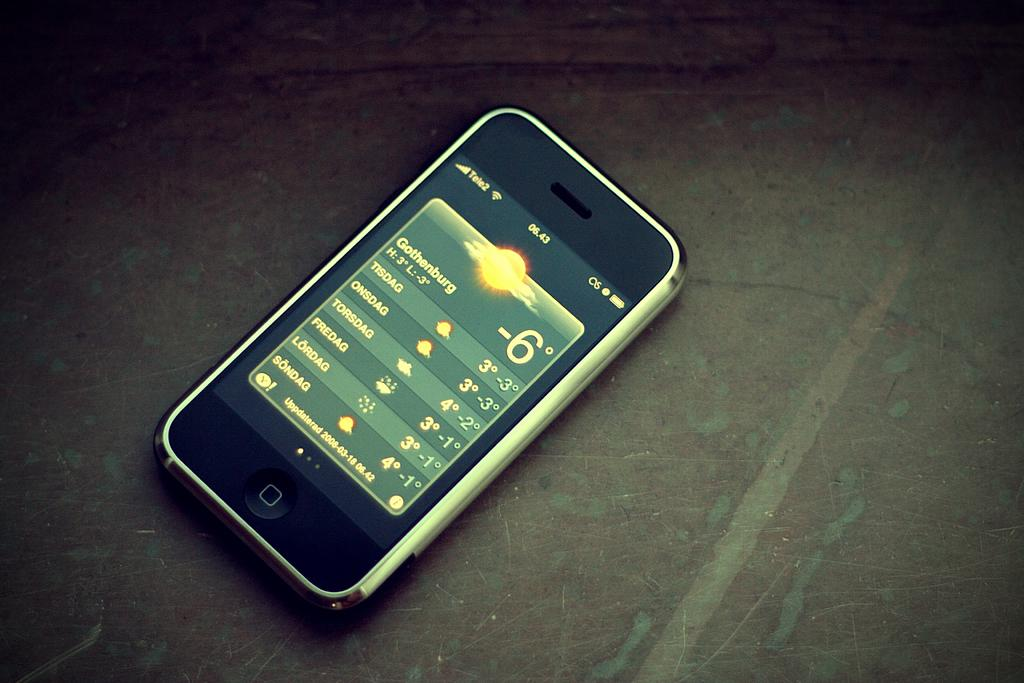<image>
Describe the image concisely. An older iPhone with the screen showing a weather forecast and the time 06.43. 